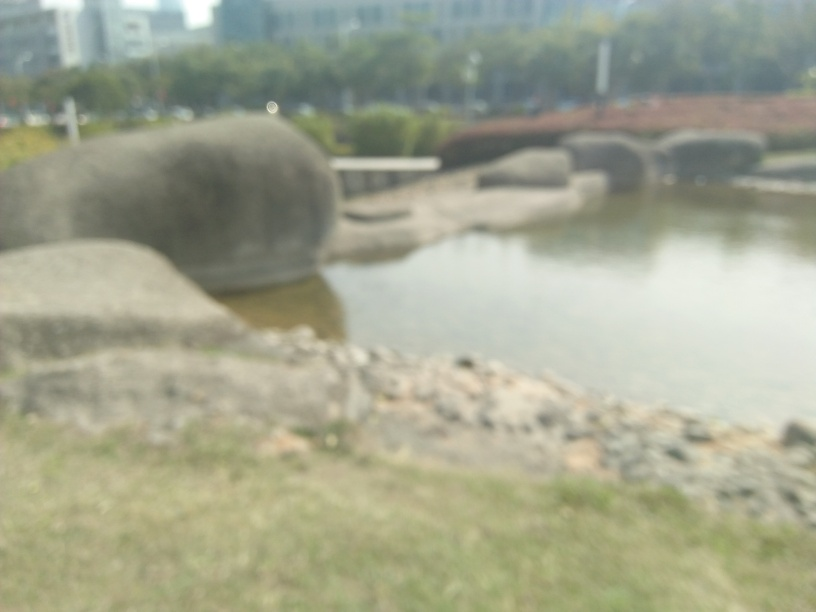Can you describe the scene in this image? The scene is quite difficult to discern due to the lack of sharpness in the image, but it appears to be an outdoor setting with large rock formations or sculptures near a body of water, possibly a park or garden. 